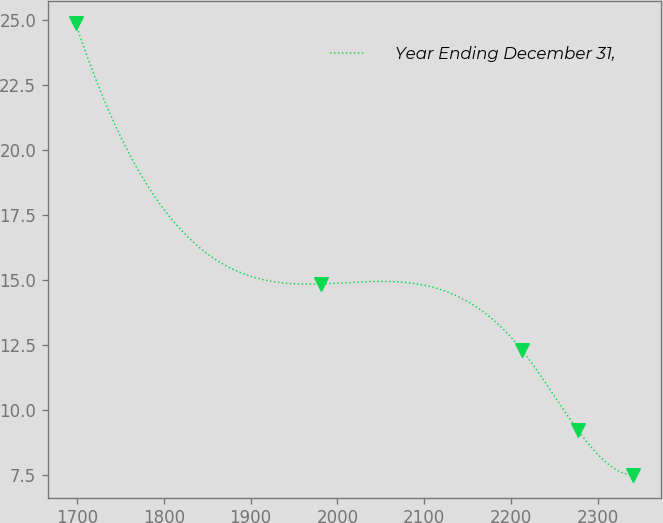Convert chart to OTSL. <chart><loc_0><loc_0><loc_500><loc_500><line_chart><ecel><fcel>Year Ending December 31,<nl><fcel>1698.64<fcel>24.87<nl><fcel>1980.72<fcel>14.85<nl><fcel>2212.8<fcel>12.29<nl><fcel>2276.51<fcel>9.24<nl><fcel>2340.22<fcel>7.5<nl></chart> 